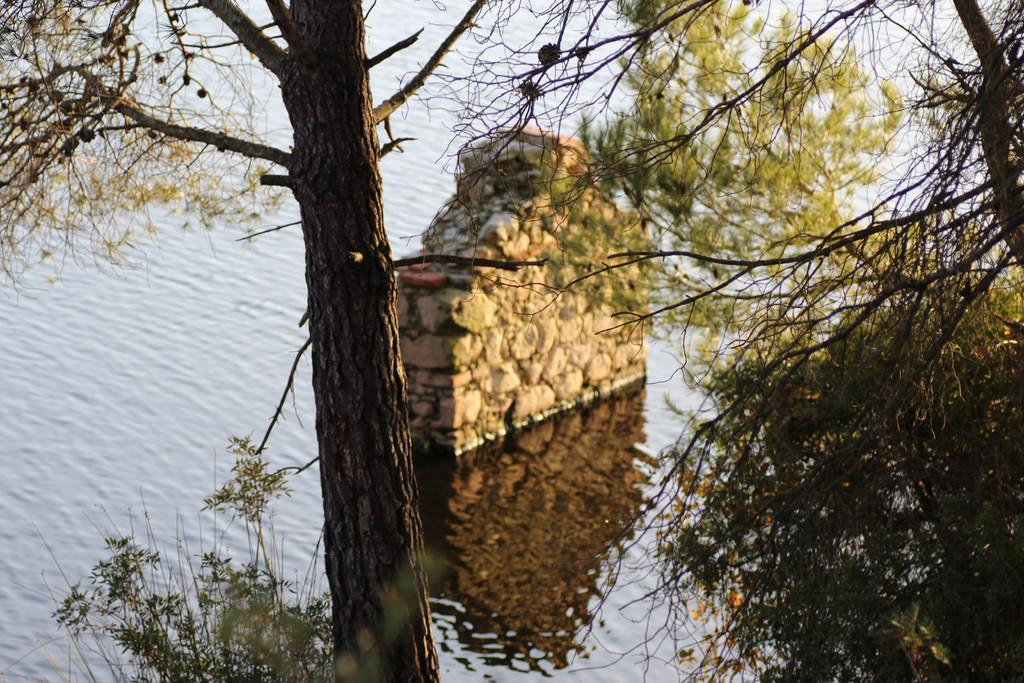What type of vegetation can be seen in the image? There are trees in the image. What natural element is visible in the image? There is water visible in the image. What type of metal can be seen in the image? There is no metal present in the image; it features trees and water. What educational institution can be seen in the image? There is no educational institution present in the image. 